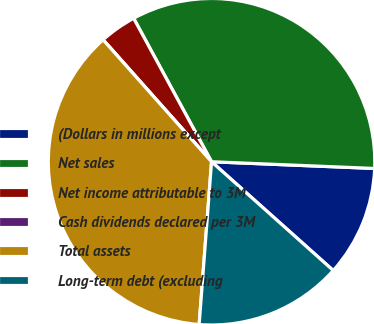<chart> <loc_0><loc_0><loc_500><loc_500><pie_chart><fcel>(Dollars in millions except<fcel>Net sales<fcel>Net income attributable to 3M<fcel>Cash dividends declared per 3M<fcel>Total assets<fcel>Long-term debt (excluding<nl><fcel>10.95%<fcel>33.57%<fcel>3.65%<fcel>0.0%<fcel>37.22%<fcel>14.6%<nl></chart> 